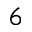Convert formula to latex. <formula><loc_0><loc_0><loc_500><loc_500>6</formula> 